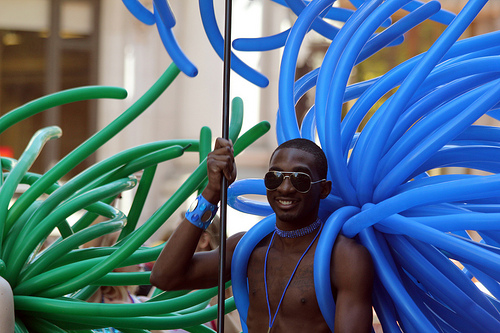<image>
Is the ballon on the chest? Yes. Looking at the image, I can see the ballon is positioned on top of the chest, with the chest providing support. Where is the man in relation to the balloons? Is it to the left of the balloons? Yes. From this viewpoint, the man is positioned to the left side relative to the balloons. Is the man next to the balloon? Yes. The man is positioned adjacent to the balloon, located nearby in the same general area. 